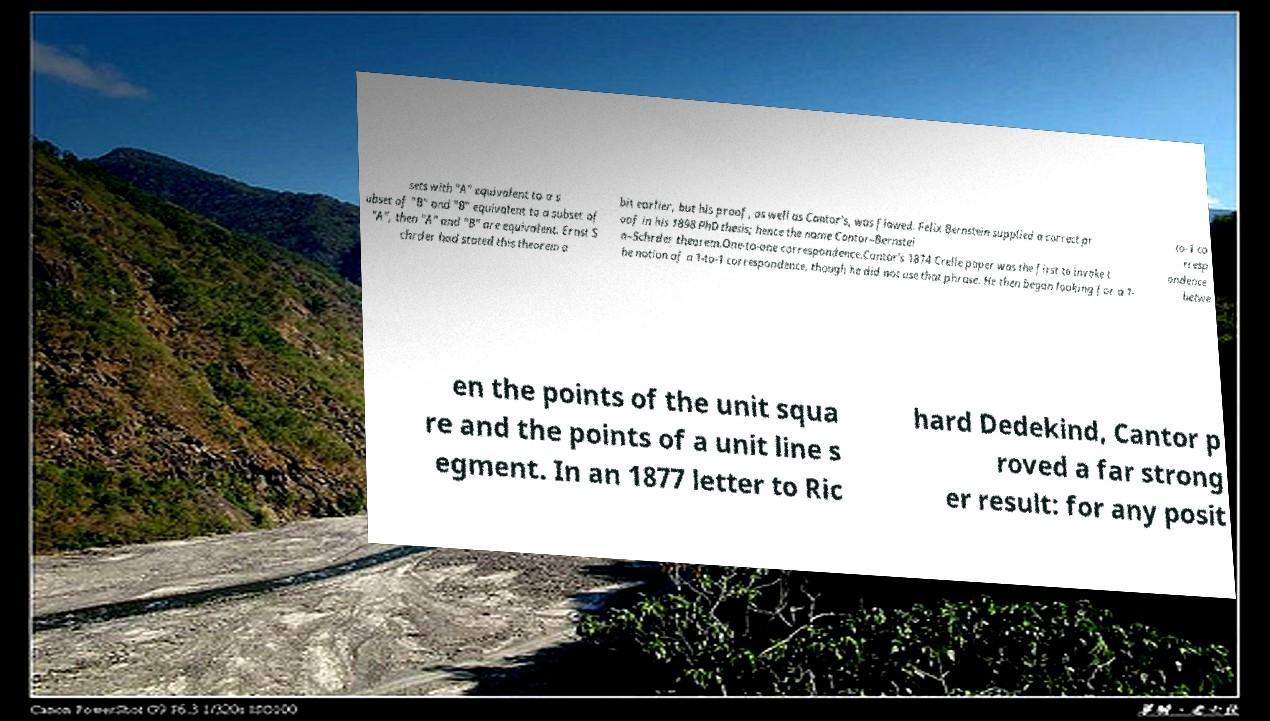What messages or text are displayed in this image? I need them in a readable, typed format. sets with "A" equivalent to a s ubset of "B" and "B" equivalent to a subset of "A", then "A" and "B" are equivalent. Ernst S chrder had stated this theorem a bit earlier, but his proof, as well as Cantor's, was flawed. Felix Bernstein supplied a correct pr oof in his 1898 PhD thesis; hence the name Cantor–Bernstei n–Schrder theorem.One-to-one correspondence.Cantor's 1874 Crelle paper was the first to invoke t he notion of a 1-to-1 correspondence, though he did not use that phrase. He then began looking for a 1- to-1 co rresp ondence betwe en the points of the unit squa re and the points of a unit line s egment. In an 1877 letter to Ric hard Dedekind, Cantor p roved a far strong er result: for any posit 